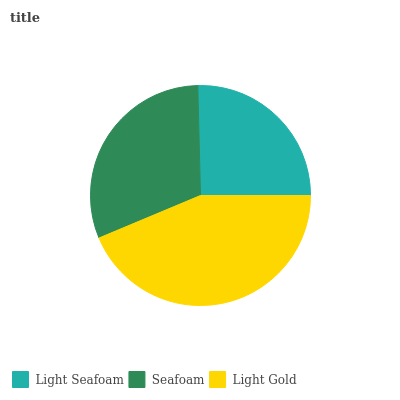Is Light Seafoam the minimum?
Answer yes or no. Yes. Is Light Gold the maximum?
Answer yes or no. Yes. Is Seafoam the minimum?
Answer yes or no. No. Is Seafoam the maximum?
Answer yes or no. No. Is Seafoam greater than Light Seafoam?
Answer yes or no. Yes. Is Light Seafoam less than Seafoam?
Answer yes or no. Yes. Is Light Seafoam greater than Seafoam?
Answer yes or no. No. Is Seafoam less than Light Seafoam?
Answer yes or no. No. Is Seafoam the high median?
Answer yes or no. Yes. Is Seafoam the low median?
Answer yes or no. Yes. Is Light Gold the high median?
Answer yes or no. No. Is Light Gold the low median?
Answer yes or no. No. 